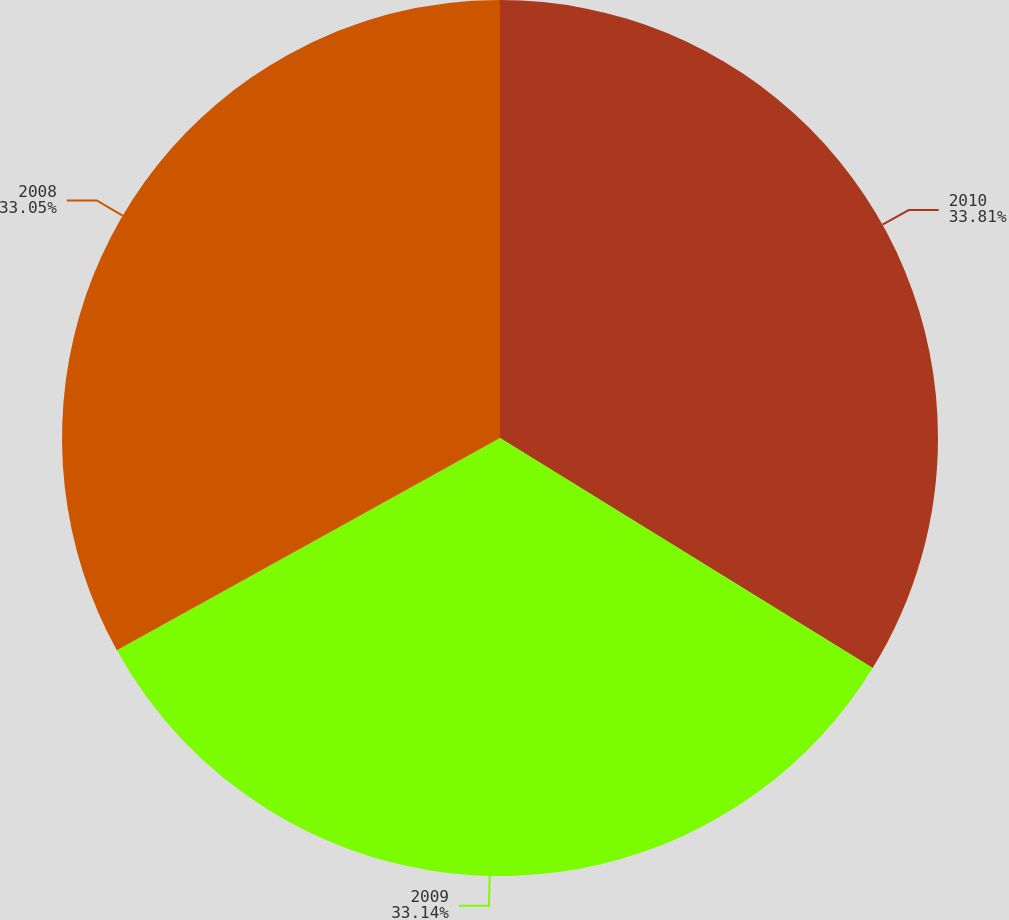<chart> <loc_0><loc_0><loc_500><loc_500><pie_chart><fcel>2010<fcel>2009<fcel>2008<nl><fcel>33.8%<fcel>33.14%<fcel>33.05%<nl></chart> 